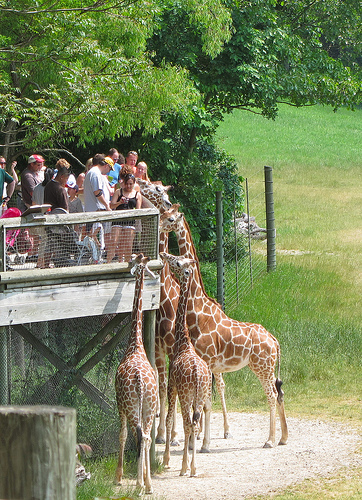How many baby giraffes are there? 2 